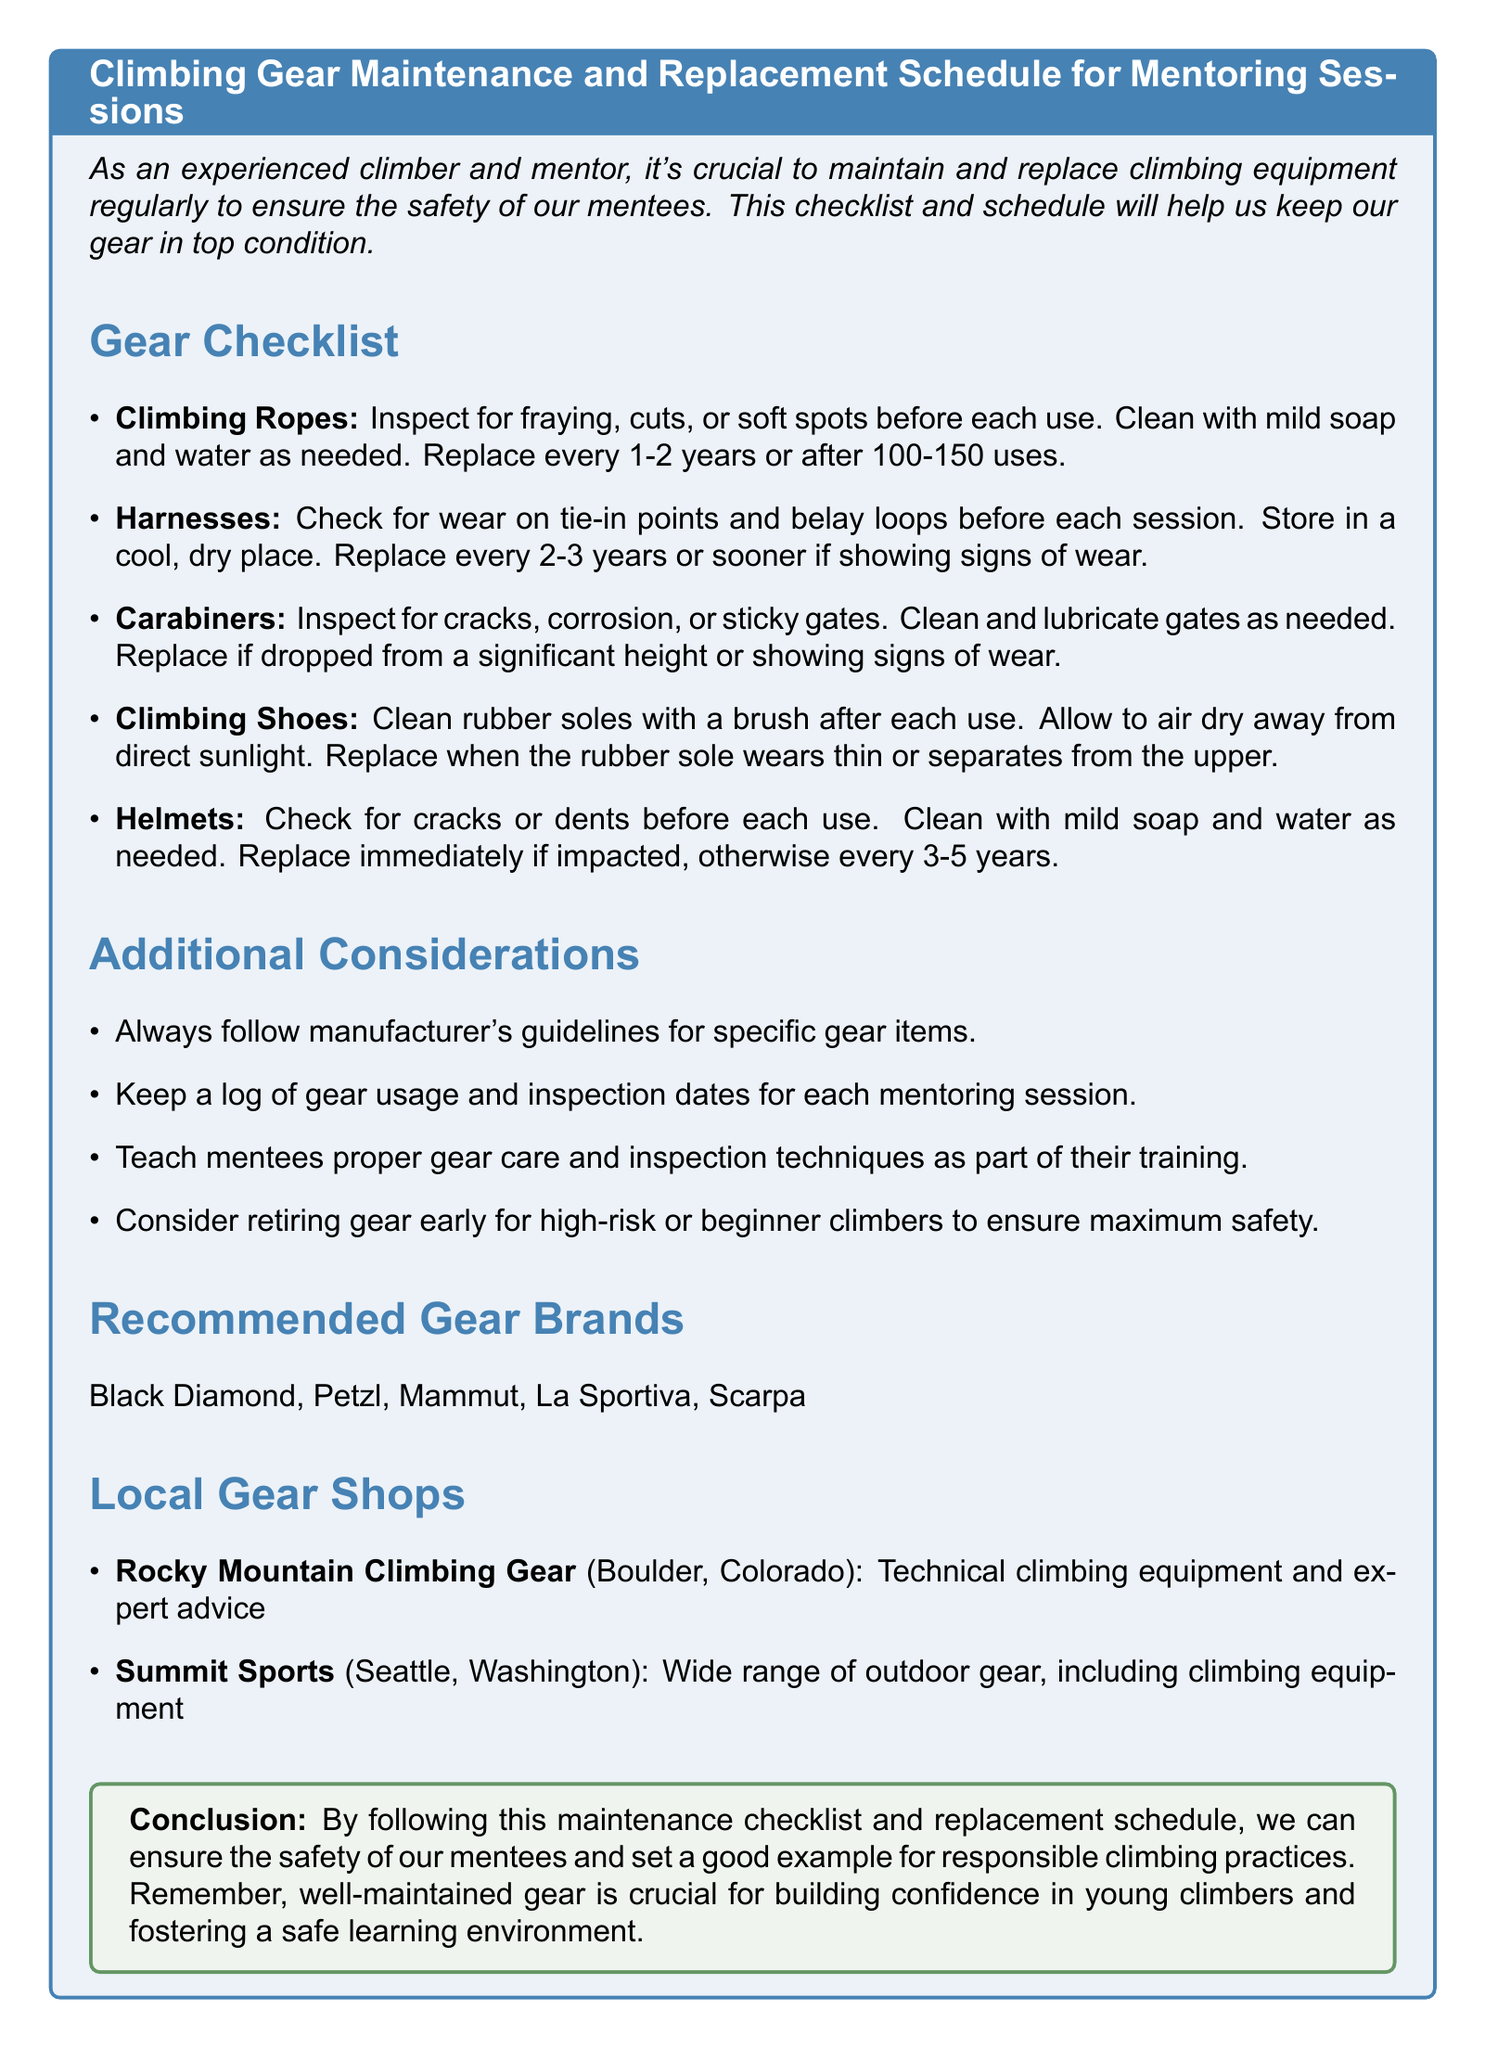What is the title of the memo? The title of the memo is explicitly stated at the beginning.
Answer: Climbing Gear Maintenance and Replacement Schedule for Mentoring Sessions What should be checked for climbing ropes before each use? The checklist specifies what to inspect for climbing ropes to ensure safety.
Answer: Fraying, cuts, or soft spots How often should climbing shoes be replaced for frequent climbers? The replacement schedule for climbing shoes indicates a typical timeframe for replacement based on usage.
Answer: Every 6-12 months What is the recommended replacement interval for helmets? The memo specifies the replacement intervals for helmets based on their condition and impact.
Answer: Every 3-5 years Which brand is suggested for climbing gear? The document lists several recommended brands for climbing gear.
Answer: Black Diamond Why is it important to keep a log of gear usage? The additional considerations section explains the reasons for maintaining logs to ensure proper gear maintenance.
Answer: For tracking inspection dates What should be done if a carabiner is dropped? The maintenance section outlines the action required if a carabiner is dropped from a height.
Answer: Replace Which local gear shop specializes in technical climbing equipment? The memo lists local gear shops and their specialties relevant to climbing.
Answer: Rocky Mountain Climbing Gear 